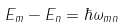<formula> <loc_0><loc_0><loc_500><loc_500>E _ { m } - E _ { n } = \hbar { \omega } _ { m n }</formula> 